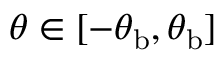Convert formula to latex. <formula><loc_0><loc_0><loc_500><loc_500>\theta \in [ - \theta _ { b } , \theta _ { b } ]</formula> 